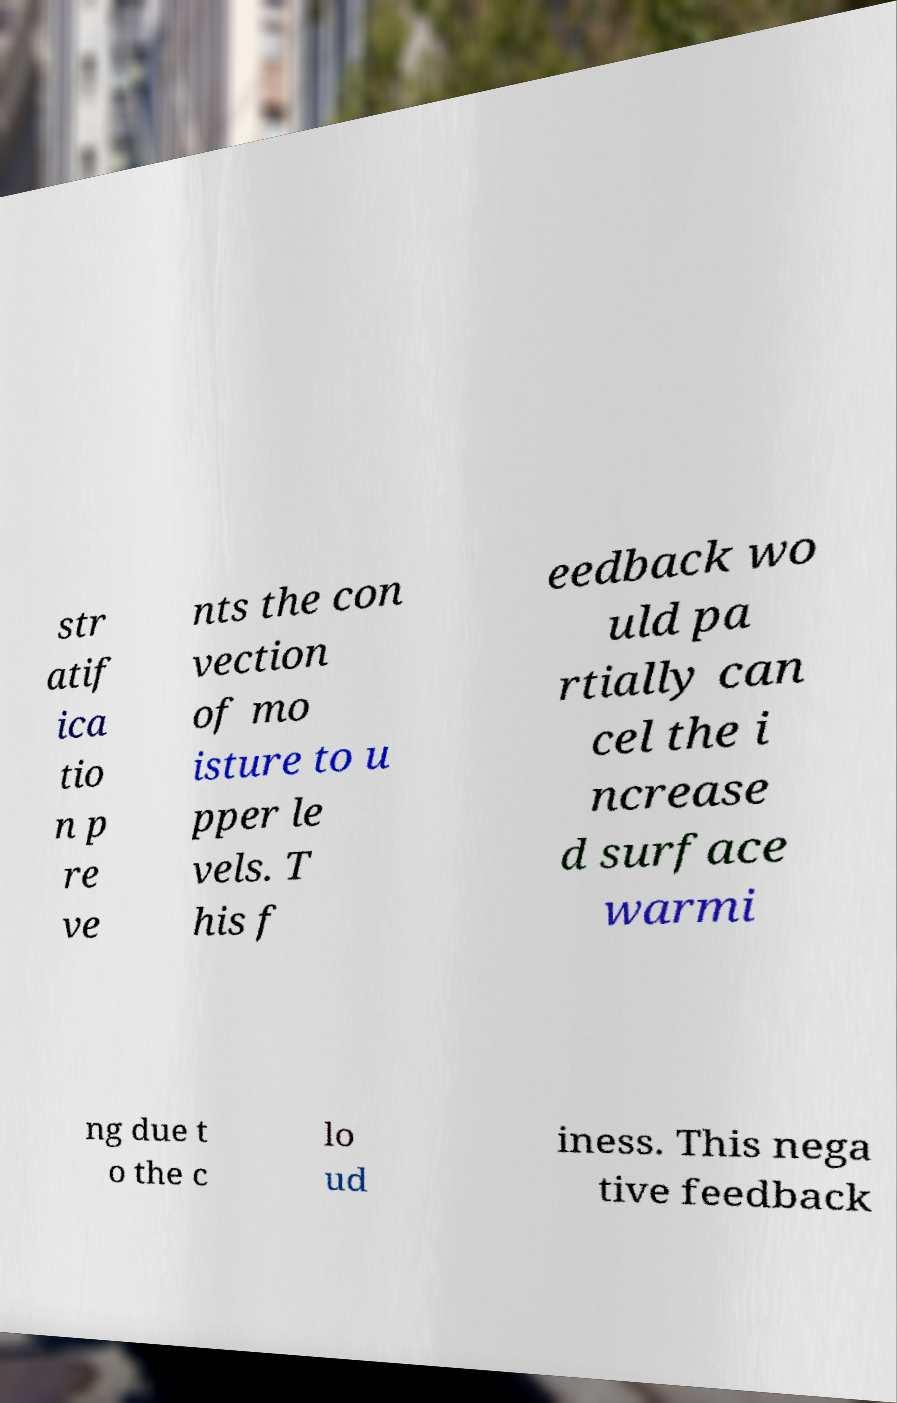What messages or text are displayed in this image? I need them in a readable, typed format. str atif ica tio n p re ve nts the con vection of mo isture to u pper le vels. T his f eedback wo uld pa rtially can cel the i ncrease d surface warmi ng due t o the c lo ud iness. This nega tive feedback 